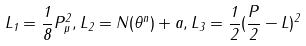Convert formula to latex. <formula><loc_0><loc_0><loc_500><loc_500>L _ { 1 } = \frac { 1 } { 8 } P _ { \mu } ^ { 2 } , L _ { 2 } = N ( \theta ^ { n } ) + a , L _ { 3 } = \frac { 1 } { 2 } ( \frac { P } { 2 } - L ) ^ { 2 }</formula> 